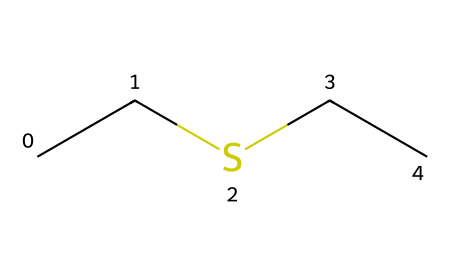What is the molecular formula of diethyl sulfide? The SMILES representation CC(S)(CC) indicates there are two ethyl groups (C2H5) attached to a sulfur atom (S). Therefore, the molecular formula includes two carbon atoms and five hydrogen atoms from each ethyl group, and one sulfur atom. This gives a total of four carbon atoms and ten hydrogen atoms along with one sulfur atom.
Answer: C4H10S How many carbon atoms are present in this compound? Analyzing the SMILES representation, we see two ethyl groups (CC), which each contain two carbon atoms, leading to a total of four carbon atoms in diethyl sulfide.
Answer: 4 What type of functional group is present in diethyl sulfide? The presence of the sulfur (S) atom bonded to two ethyl groups indicates that this is a thioether, a type of functional group characterized by the sulfur atom bonded to two alkyl or aryl groups.
Answer: thioether What is the total number of atoms in diethyl sulfide? To find the total number of atoms, we add the carbon atoms (4), hydrogen atoms (10), and the sulfur atom (1), leading to a total of 15 atoms in the compound.
Answer: 15 How many bonds are formed between the carbon and sulfur atoms? In diethyl sulfide, the sulfur atom is connected to the two carbon chains (ethyl groups) through single bonds, indicating a total of two carbon-sulfur bonds in the molecular structure.
Answer: 2 Is diethyl sulfide categorized as an aliphatic or aromatic compound? The structure of diethyl sulfide, which consists only of carbon chains without any cyclic or benzene-like structures, categorizes it as an aliphatic compound.
Answer: aliphatic 